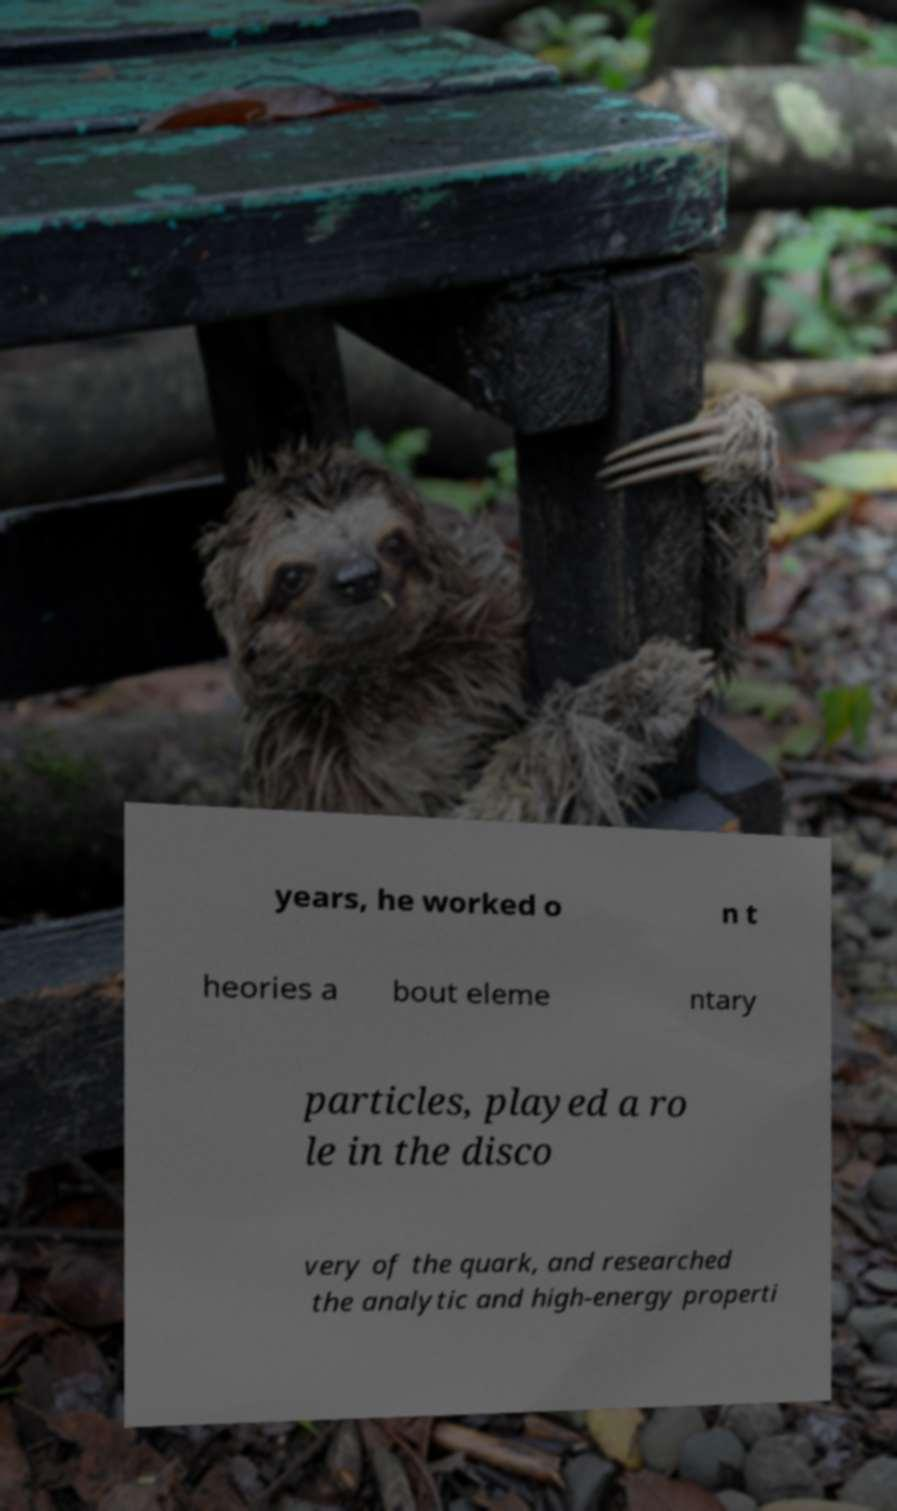There's text embedded in this image that I need extracted. Can you transcribe it verbatim? years, he worked o n t heories a bout eleme ntary particles, played a ro le in the disco very of the quark, and researched the analytic and high-energy properti 